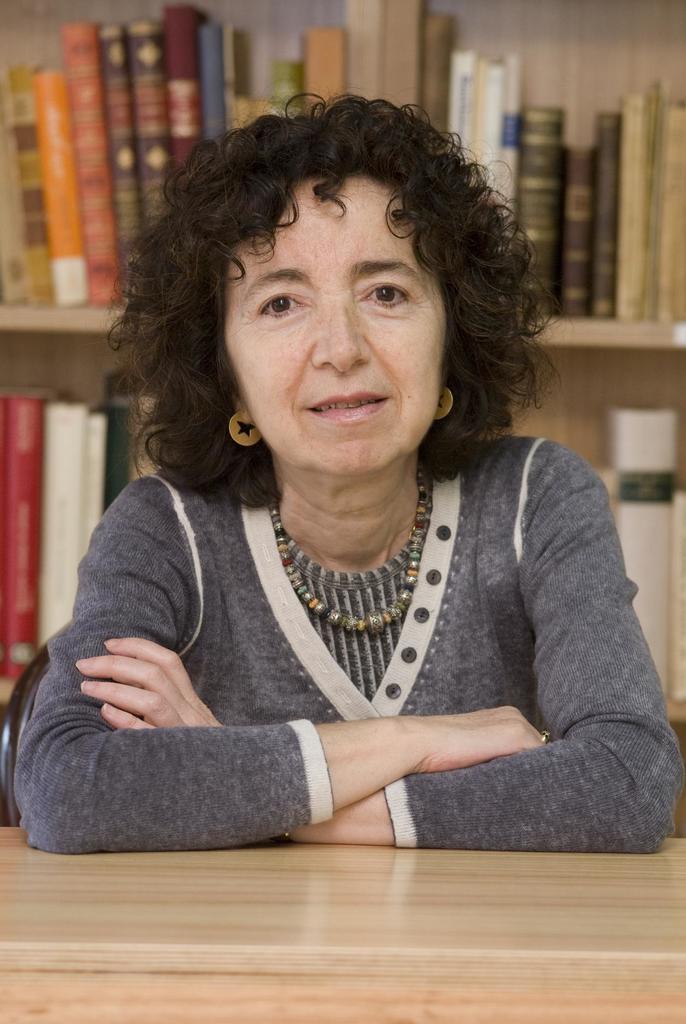Please provide a concise description of this image. In front of the picture, we see the woman in the grey t-shirt is sitting on the chair. She is smiling. I think she is posing for the photo. In front of her, we see a table. Behind her, we see a rack in which books are placed. This picture might be clicked in the library. 